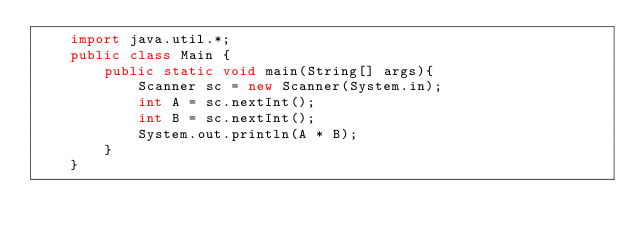Convert code to text. <code><loc_0><loc_0><loc_500><loc_500><_Java_>    import java.util.*;
    public class Main {
    	public static void main(String[] args){
    		Scanner sc = new Scanner(System.in);
    		int A = sc.nextInt();
    		int B = sc.nextInt();
    		System.out.println(A * B);
    	}
    }</code> 